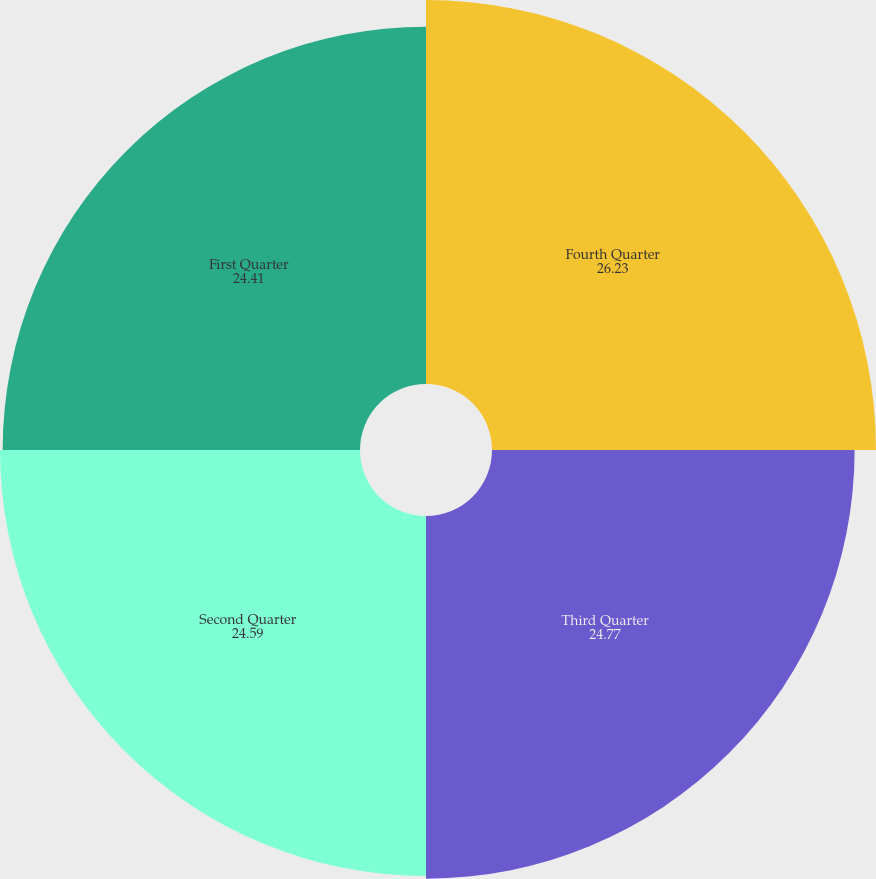<chart> <loc_0><loc_0><loc_500><loc_500><pie_chart><fcel>Fourth Quarter<fcel>Third Quarter<fcel>Second Quarter<fcel>First Quarter<nl><fcel>26.23%<fcel>24.77%<fcel>24.59%<fcel>24.41%<nl></chart> 